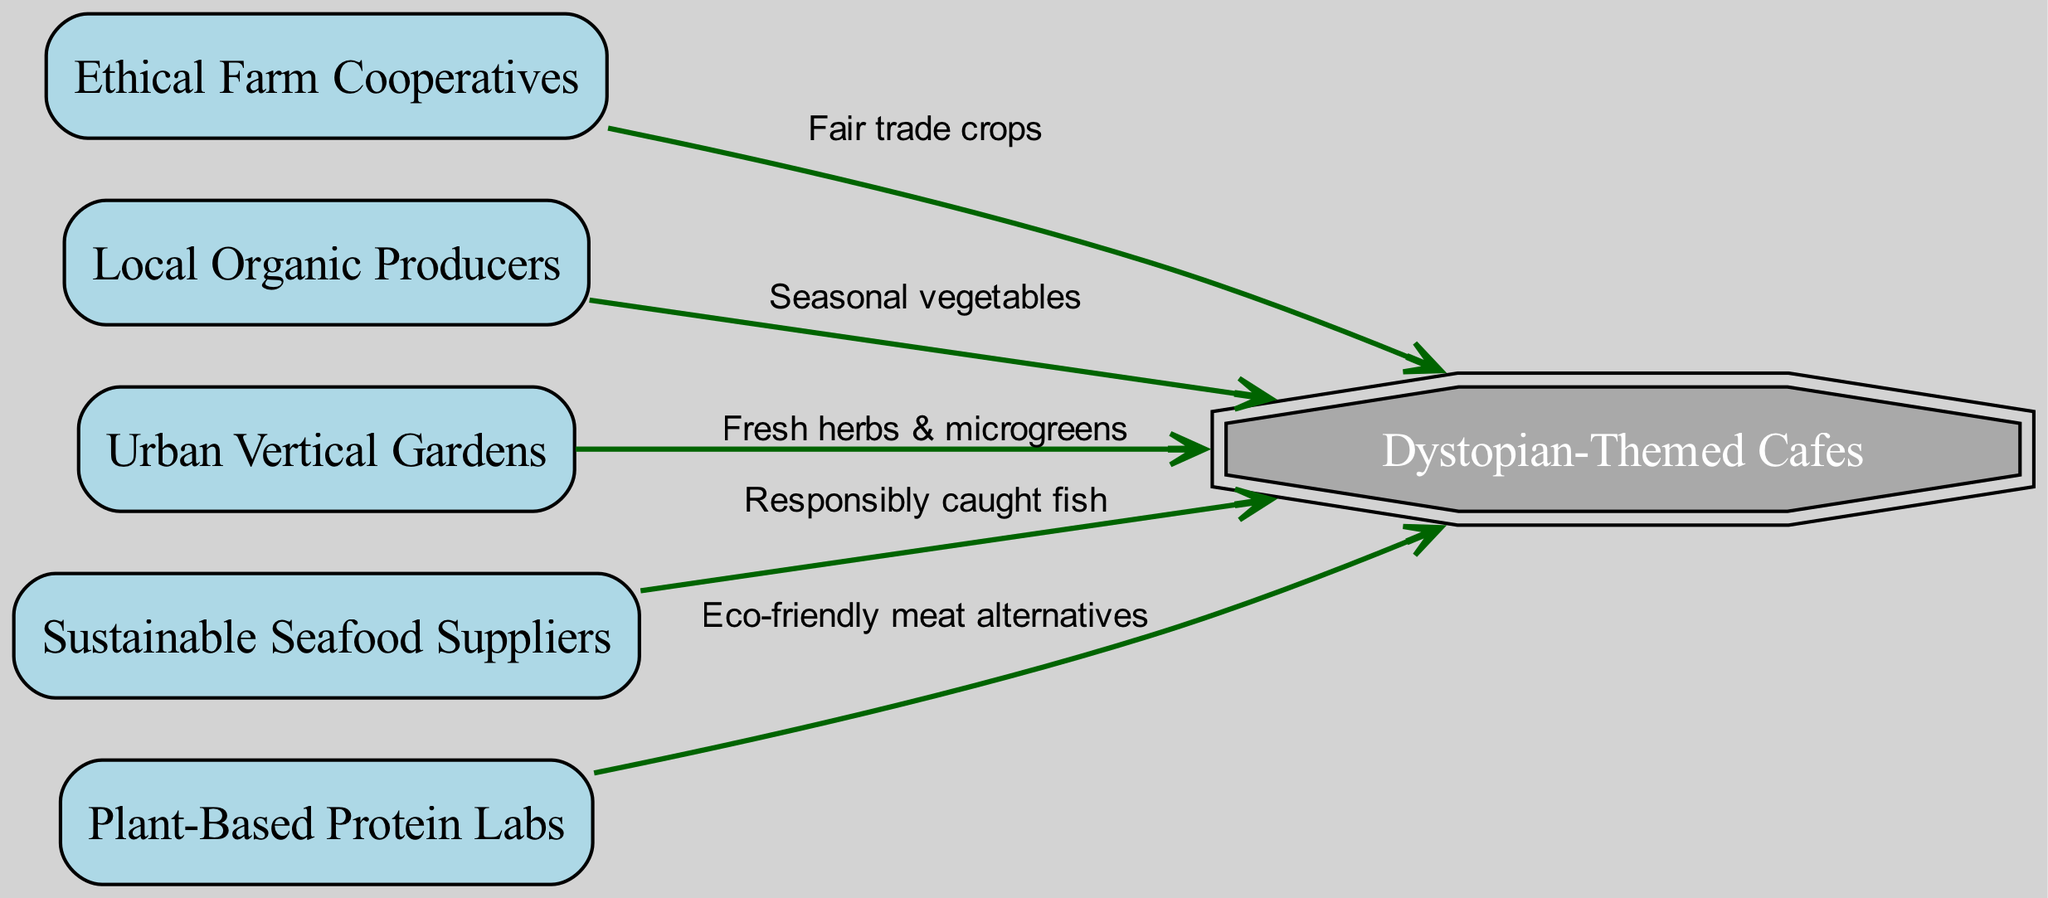What is the total number of nodes in the diagram? The diagram includes six distinct nodes, specifically: Ethical Farm Cooperatives, Local Organic Producers, Urban Vertical Gardens, Sustainable Seafood Suppliers, Plant-Based Protein Labs, and Dystopian-Themed Cafes.
Answer: 6 What type of crops do Ethical Farm Cooperatives provide to Dystopian-Themed Cafes? The connection from Ethical Farm Cooperatives to Dystopian-Themed Cafes indicates "Fair trade crops." This label directly shows the type of produce sourced.
Answer: Fair trade crops Which node provides "Seasonal vegetables"? The Local Organic Producers node has a direct edge to Dystopian-Themed Cafes labeled with "Seasonal vegetables," clearly showing that this type of produce is sourced from here.
Answer: Local Organic Producers What is the edge label connecting Urban Vertical Gardens to Dystopian-Themed Cafes? The edge that flows from Urban Vertical Gardens to Dystopian-Themed Cafes contains the label "Fresh herbs & microgreens," indicating what is provided through this connection.
Answer: Fresh herbs & microgreens How many nodes are directly connected to Dystopian-Themed Cafes? Five nodes connect directly to Dystopian-Themed Cafes: Ethical Farm Cooperatives, Local Organic Producers, Urban Vertical Gardens, Sustainable Seafood Suppliers, and Plant-Based Protein Labs.
Answer: 5 Which node supplies "Eco-friendly meat alternatives" to Dystopian-Themed Cafes? The Plant-Based Protein Labs node specifically provides "Eco-friendly meat alternatives" as indicated by the edge label connecting to Dystopian-Themed Cafes.
Answer: Plant-Based Protein Labs What type of fish is sourced from Sustainable Seafood Suppliers? The label on the edge connecting Sustainable Seafood Suppliers to Dystopian-Themed Cafes specifies "Responsibly caught fish," thereby indicating the type of seafood provided.
Answer: Responsibly caught fish Which node has the most connections to Dystopian-Themed Cafes? The Dystopian-Themed Cafes node links to five different sources representing the entire sustainable food chain, showing its comprehensive sourcing strategy.
Answer: Dystopian-Themed Cafes Is there a food source in the chain that is plant-based? Yes, the Plant-Based Protein Labs node represents a source that solely focuses on plant-based options for Dystopian-Themed Cafes, providing eco-friendly alternatives.
Answer: Yes 